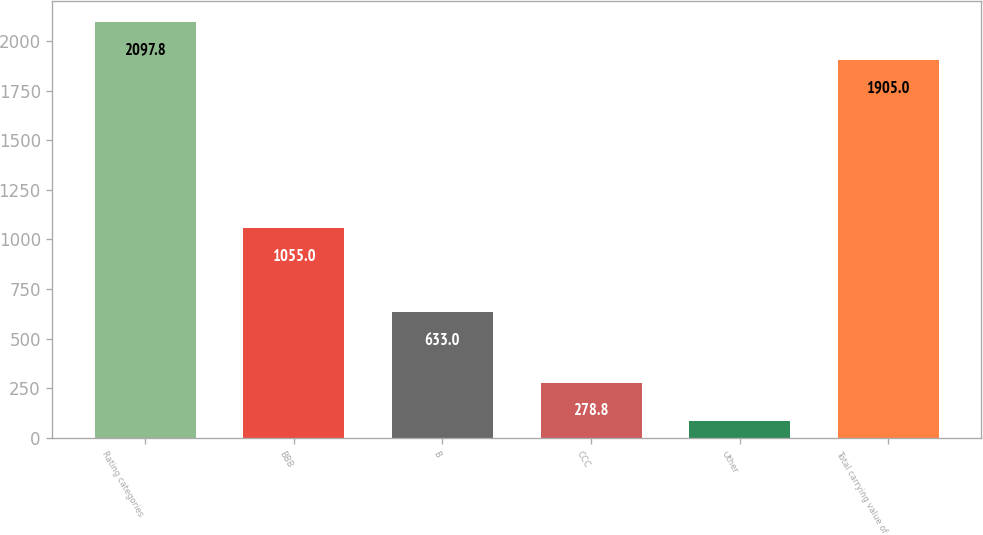Convert chart. <chart><loc_0><loc_0><loc_500><loc_500><bar_chart><fcel>Rating categories<fcel>BBB<fcel>B<fcel>CCC<fcel>Other<fcel>Total carrying value of<nl><fcel>2097.8<fcel>1055<fcel>633<fcel>278.8<fcel>86<fcel>1905<nl></chart> 